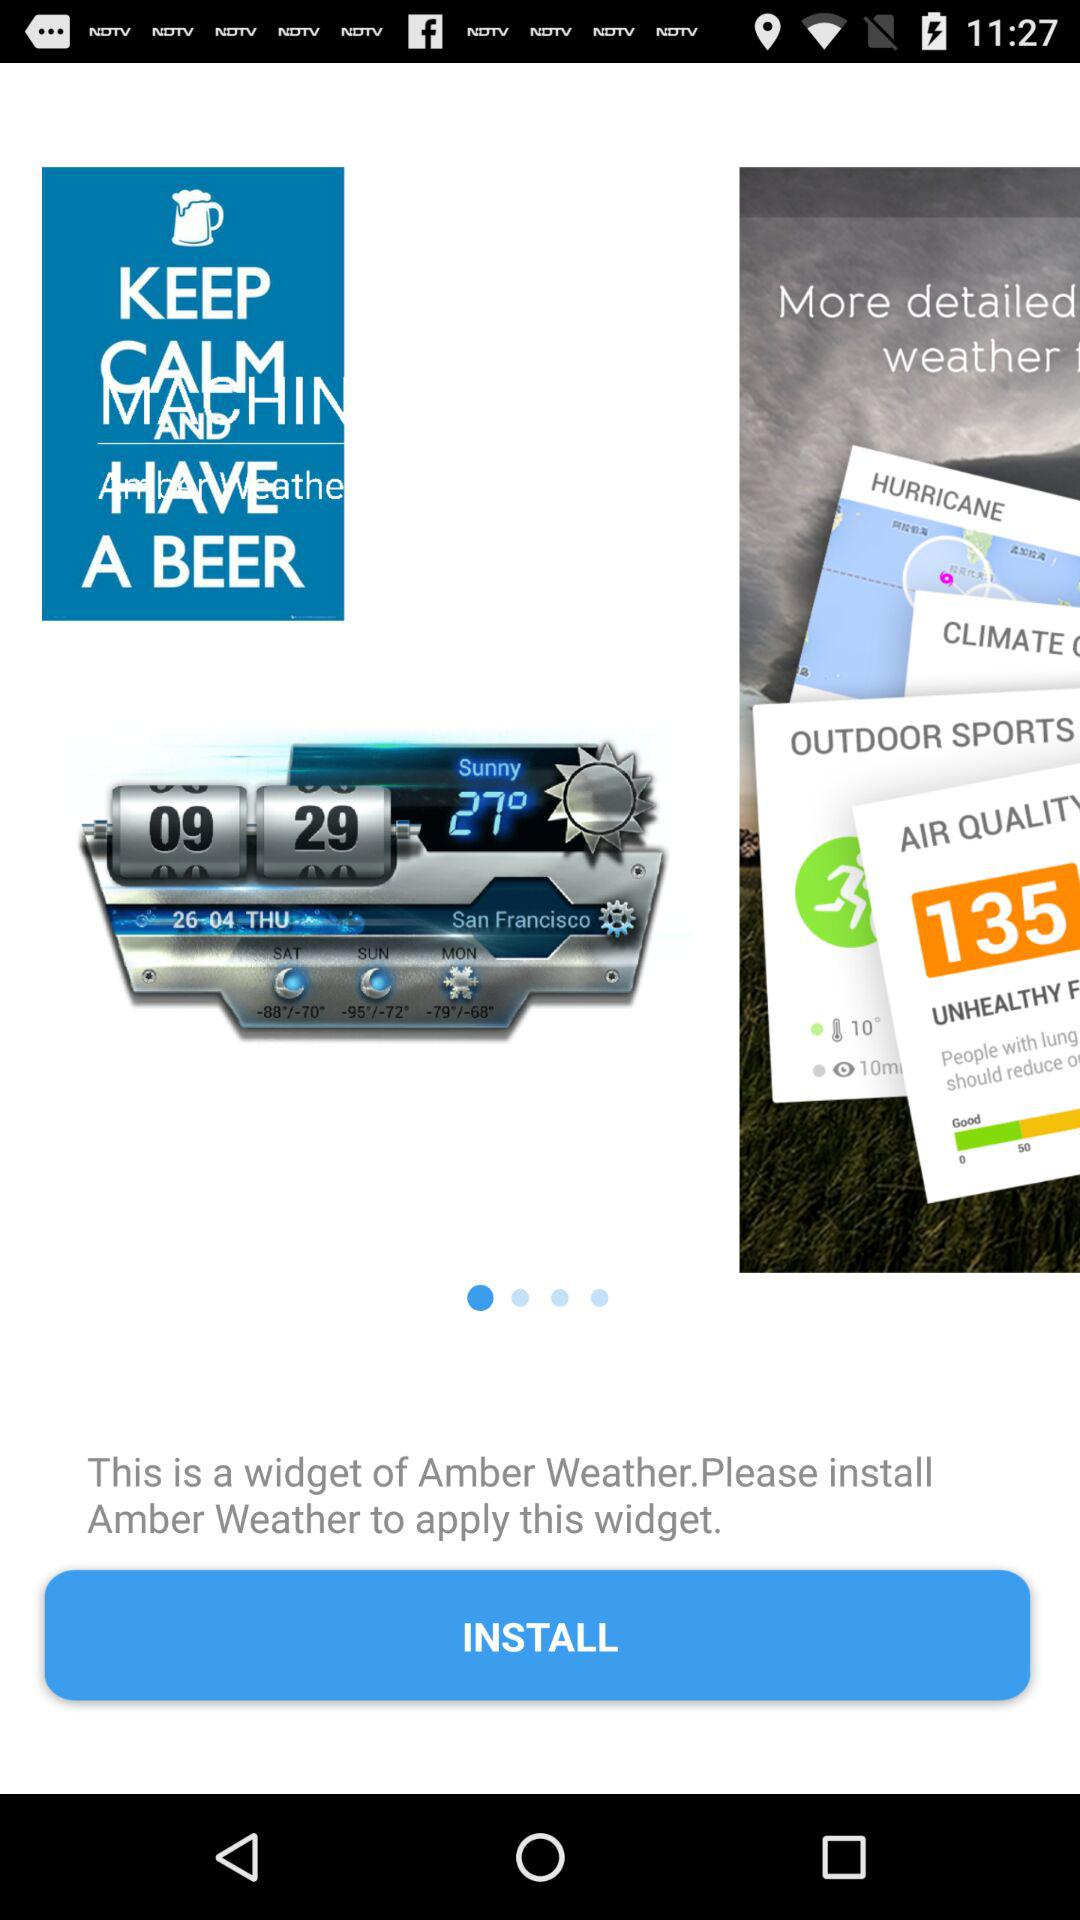What is the date in San Francisco? The date is Thursday, April 26. 